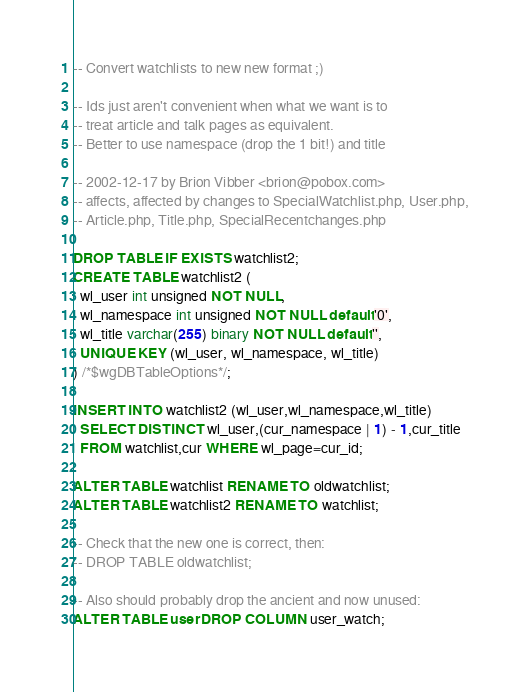<code> <loc_0><loc_0><loc_500><loc_500><_SQL_>-- Convert watchlists to new new format ;)

-- Ids just aren't convenient when what we want is to
-- treat article and talk pages as equivalent.
-- Better to use namespace (drop the 1 bit!) and title

-- 2002-12-17 by Brion Vibber <brion@pobox.com>
-- affects, affected by changes to SpecialWatchlist.php, User.php,
-- Article.php, Title.php, SpecialRecentchanges.php

DROP TABLE IF EXISTS watchlist2;
CREATE TABLE watchlist2 (
  wl_user int unsigned NOT NULL,
  wl_namespace int unsigned NOT NULL default '0',
  wl_title varchar(255) binary NOT NULL default '',
  UNIQUE KEY (wl_user, wl_namespace, wl_title)
) /*$wgDBTableOptions*/;

INSERT INTO watchlist2 (wl_user,wl_namespace,wl_title)
  SELECT DISTINCT wl_user,(cur_namespace | 1) - 1,cur_title
  FROM watchlist,cur WHERE wl_page=cur_id;

ALTER TABLE watchlist RENAME TO oldwatchlist;
ALTER TABLE watchlist2 RENAME TO watchlist;

-- Check that the new one is correct, then:
-- DROP TABLE oldwatchlist;

-- Also should probably drop the ancient and now unused:
ALTER TABLE user DROP COLUMN user_watch;
</code> 